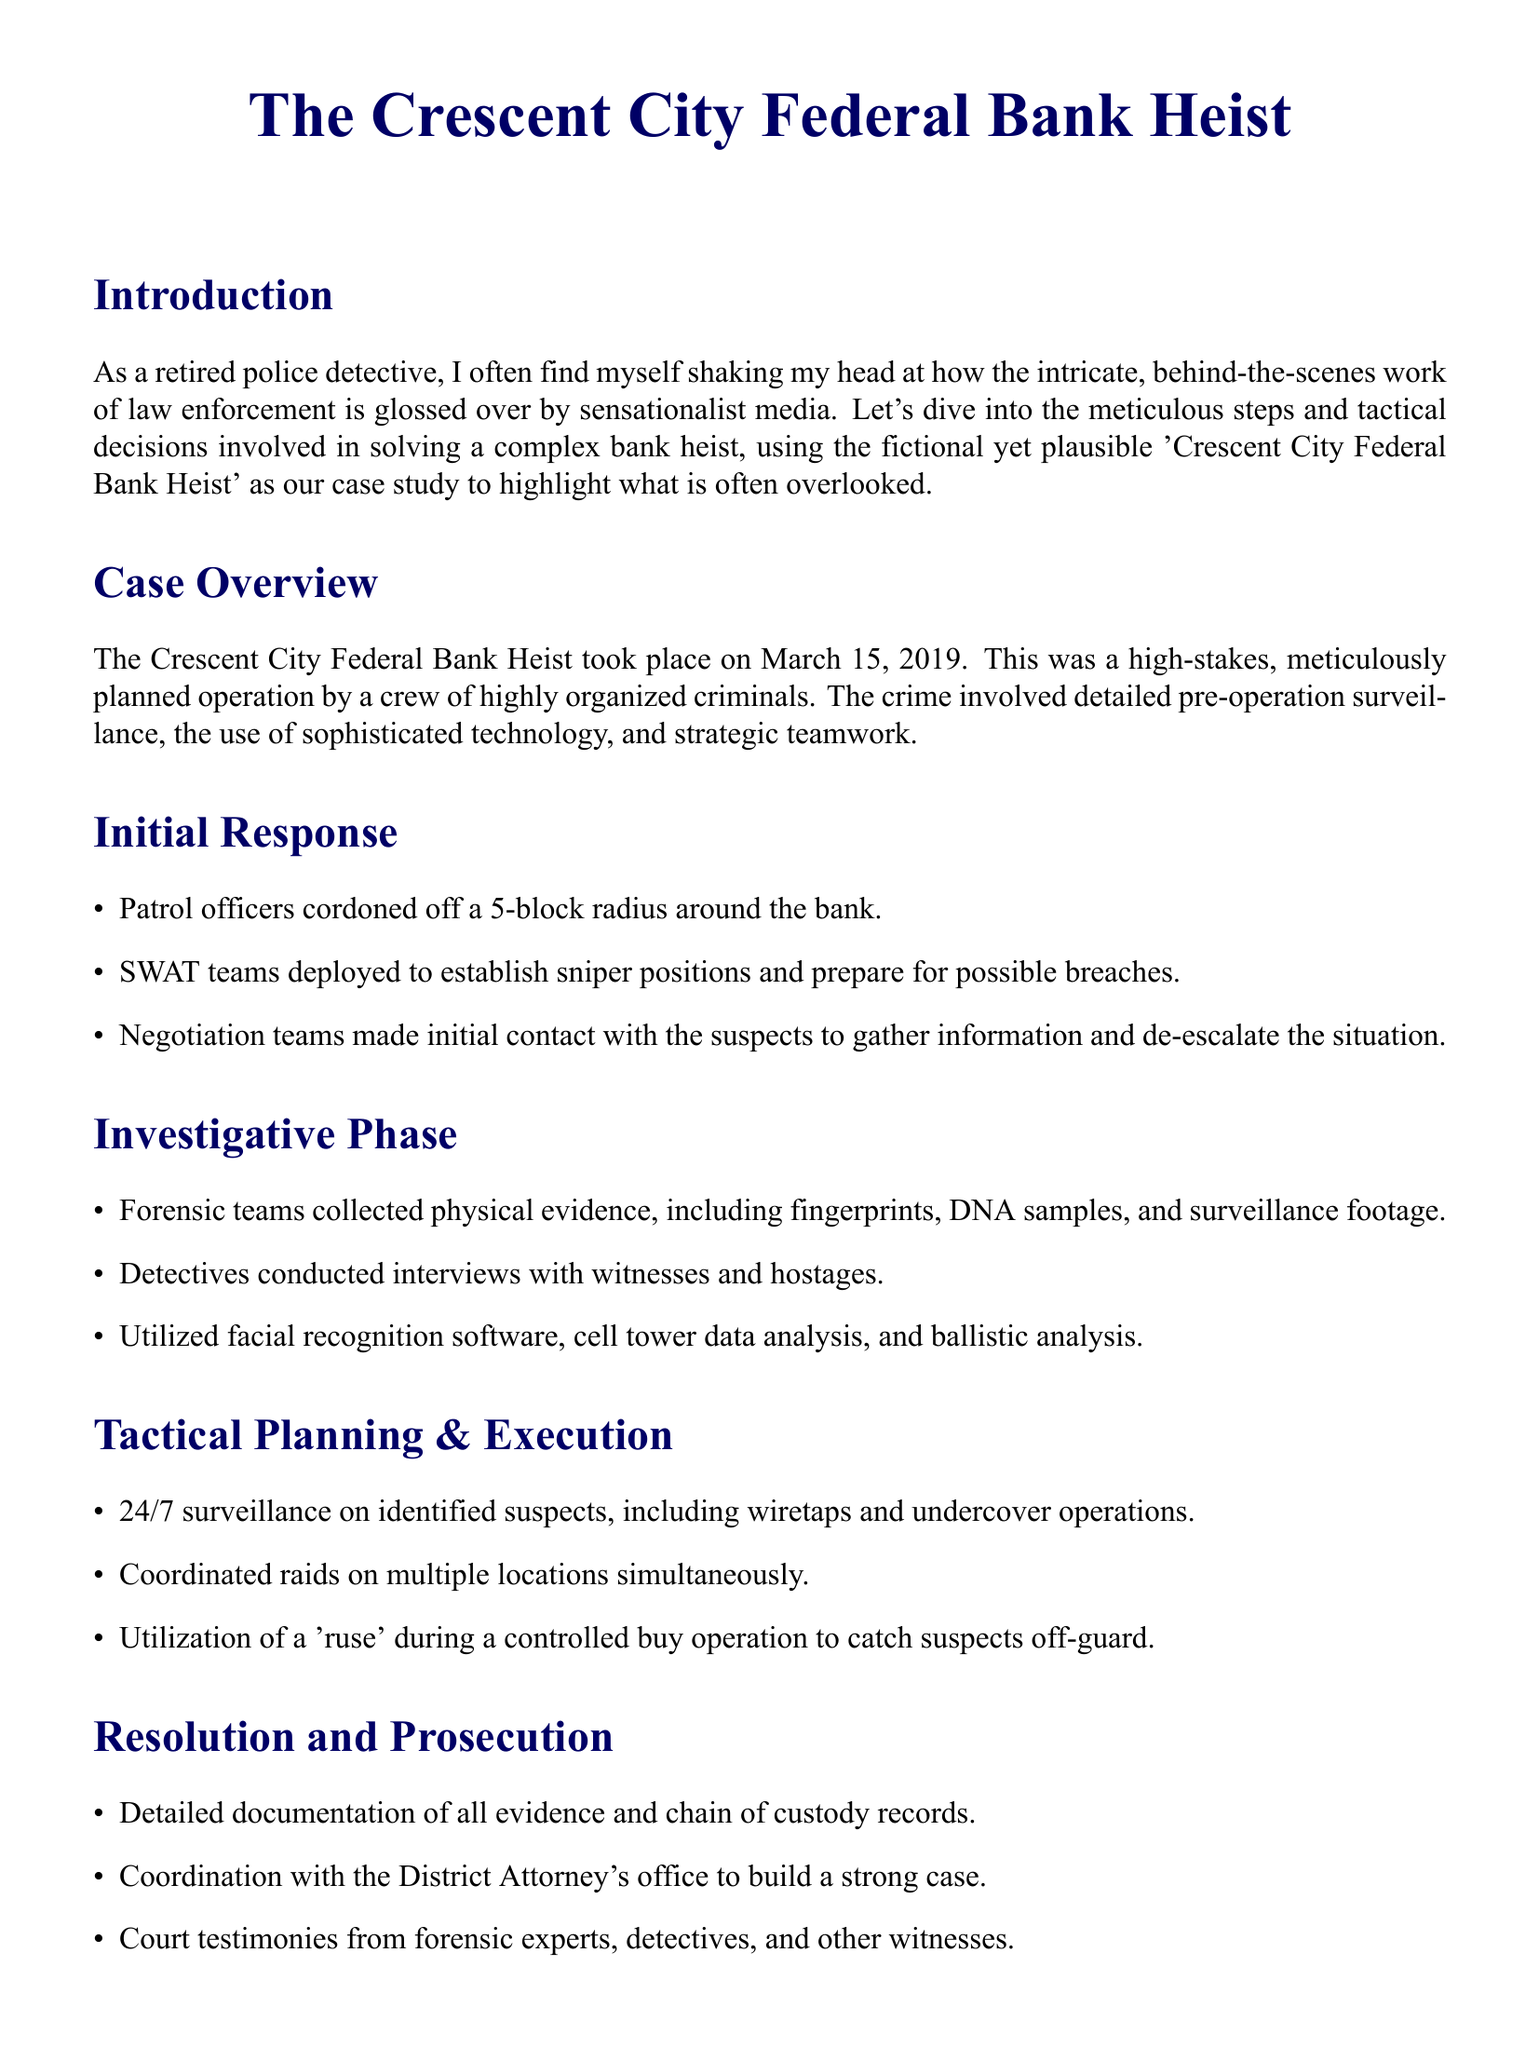What date did the Crescent City Federal Bank Heist occur? The date is explicitly mentioned in the case overview section of the document.
Answer: March 15, 2019 What was one of the initial responses by patrol officers? This information can be found in the initial response section, listing actions taken.
Answer: Cordoned off a 5-block radius What kind of technology was utilized during the investigative phase? This requires summarizing the methods mentioned in the investigative phase section.
Answer: Facial recognition software What strategy was employed during the tactical planning and execution phase? This question asks about a specific tactic detailed in the tactics section of the document.
Answer: Utilization of a 'ruse' Who coordinated with the District Attorney's office? The role of the individuals involved in the resolution phase is explicitly discussed.
Answer: Detectives How was evidence documented after the crime? The method of documentation is specified in the resolution and prosecution section.
Answer: Chain of custody records What type of teams made initial contact with the suspects? This question focuses on the initial response section mentioning responding teams.
Answer: Negotiation teams What does the conclusion highlight about solving crimes? The conclusion summarizes the overall focus of the document’s message.
Answer: Painstaking detail and coordinated efforts 